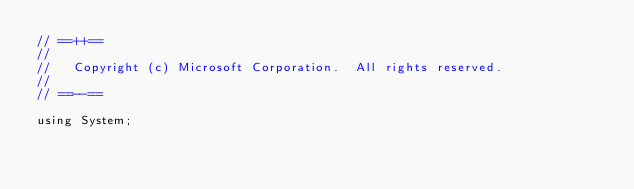Convert code to text. <code><loc_0><loc_0><loc_500><loc_500><_C#_>// ==++==
//
//   Copyright (c) Microsoft Corporation.  All rights reserved.
//
// ==--==

using System;</code> 